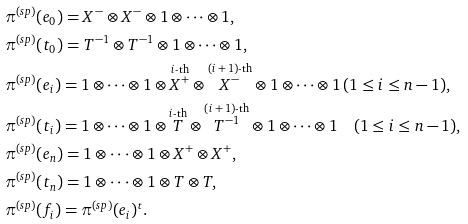Convert formula to latex. <formula><loc_0><loc_0><loc_500><loc_500>& \pi ^ { ( s p ) } ( e _ { 0 } ) = X ^ { - } \otimes X ^ { - } \otimes 1 \otimes \cdots \otimes 1 , \\ & \pi ^ { ( s p ) } ( t _ { 0 } ) = T ^ { - 1 } \otimes T ^ { - 1 } \otimes 1 \otimes \cdots \otimes 1 , \\ & \pi ^ { ( s p ) } ( e _ { i } ) = 1 \otimes \cdots \otimes 1 \otimes \overset { \text {$i$-th} } { X ^ { + } } \otimes \overset { \text {$(i+1)$-th} } { X ^ { - } } \otimes 1 \otimes \cdots \otimes 1 \, ( 1 \leq i \leq n - 1 ) , \\ & \pi ^ { ( s p ) } ( t _ { i } ) = 1 \otimes \cdots \otimes 1 \otimes \overset { \text {$i$-th} } { T } \otimes \overset { \text {$(i+1)$-th} } { T ^ { - 1 } } \otimes 1 \otimes \cdots \otimes 1 \quad ( 1 \leq i \leq n - 1 ) , \\ & \pi ^ { ( s p ) } ( e _ { n } ) = 1 \otimes \cdot \cdot \cdot \otimes 1 \otimes X ^ { + } \otimes X ^ { + } , \\ & \pi ^ { ( s p ) } ( t _ { n } ) = 1 \otimes \cdot \cdot \cdot \otimes 1 \otimes T \otimes T , \\ & \pi ^ { ( s p ) } ( f _ { i } ) = \pi ^ { ( s p ) } ( e _ { i } ) ^ { t } .</formula> 